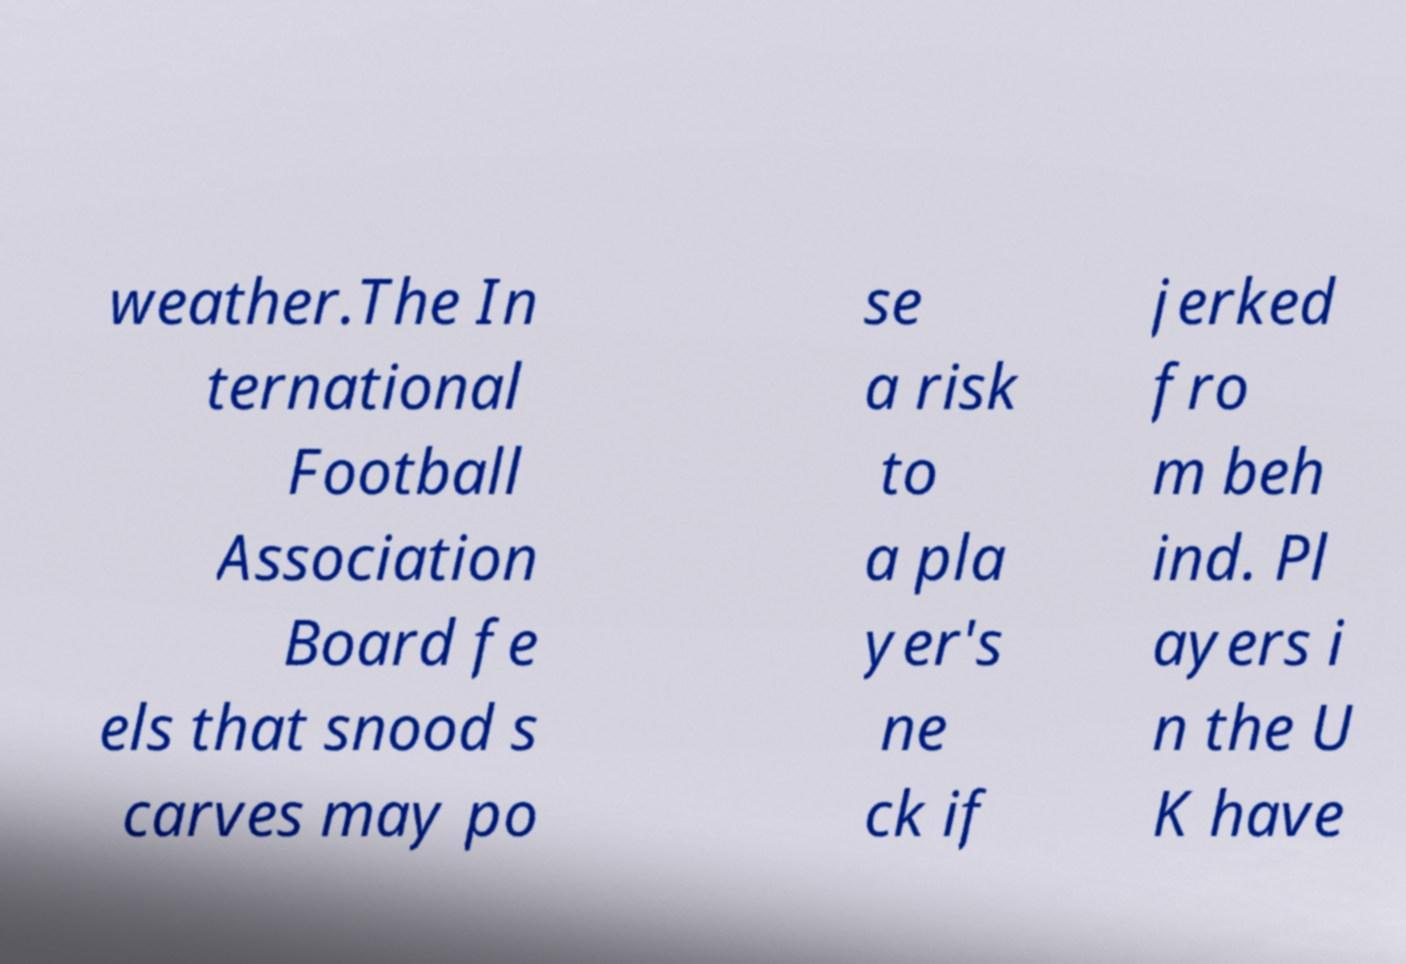Please identify and transcribe the text found in this image. weather.The In ternational Football Association Board fe els that snood s carves may po se a risk to a pla yer's ne ck if jerked fro m beh ind. Pl ayers i n the U K have 